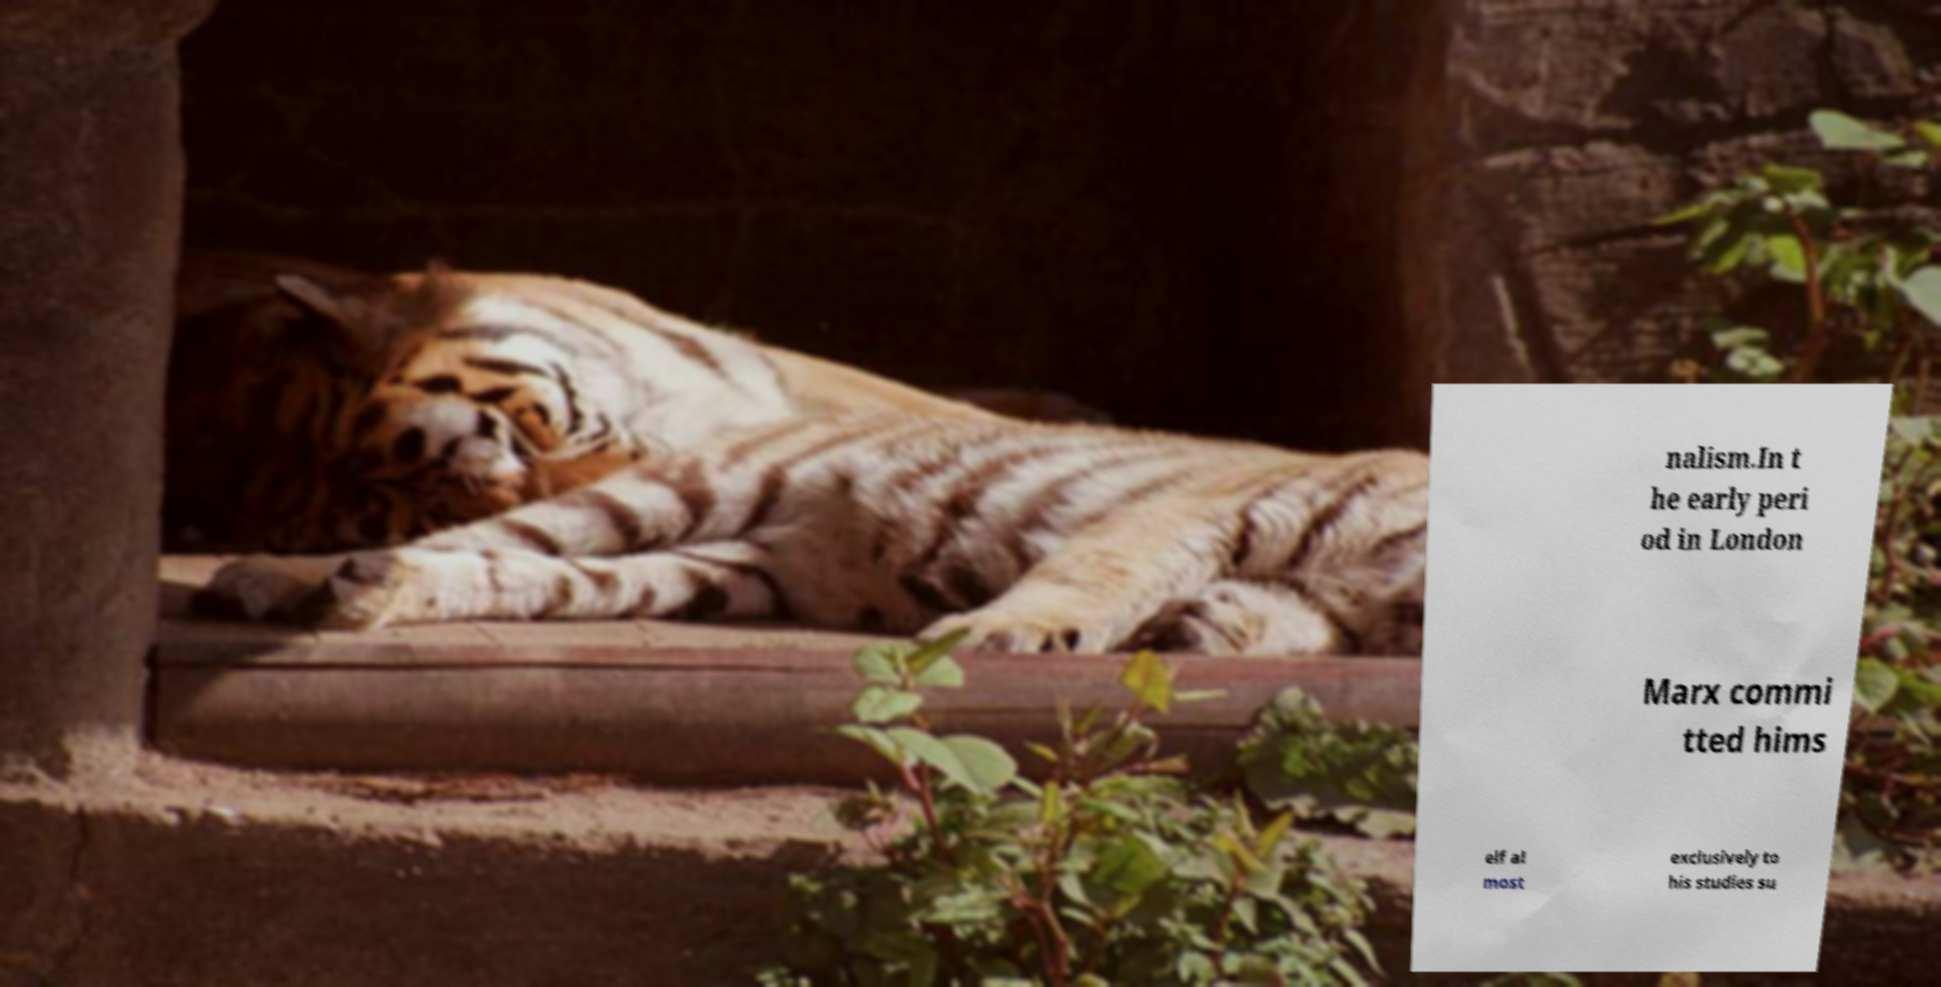Could you assist in decoding the text presented in this image and type it out clearly? nalism.In t he early peri od in London Marx commi tted hims elf al most exclusively to his studies su 